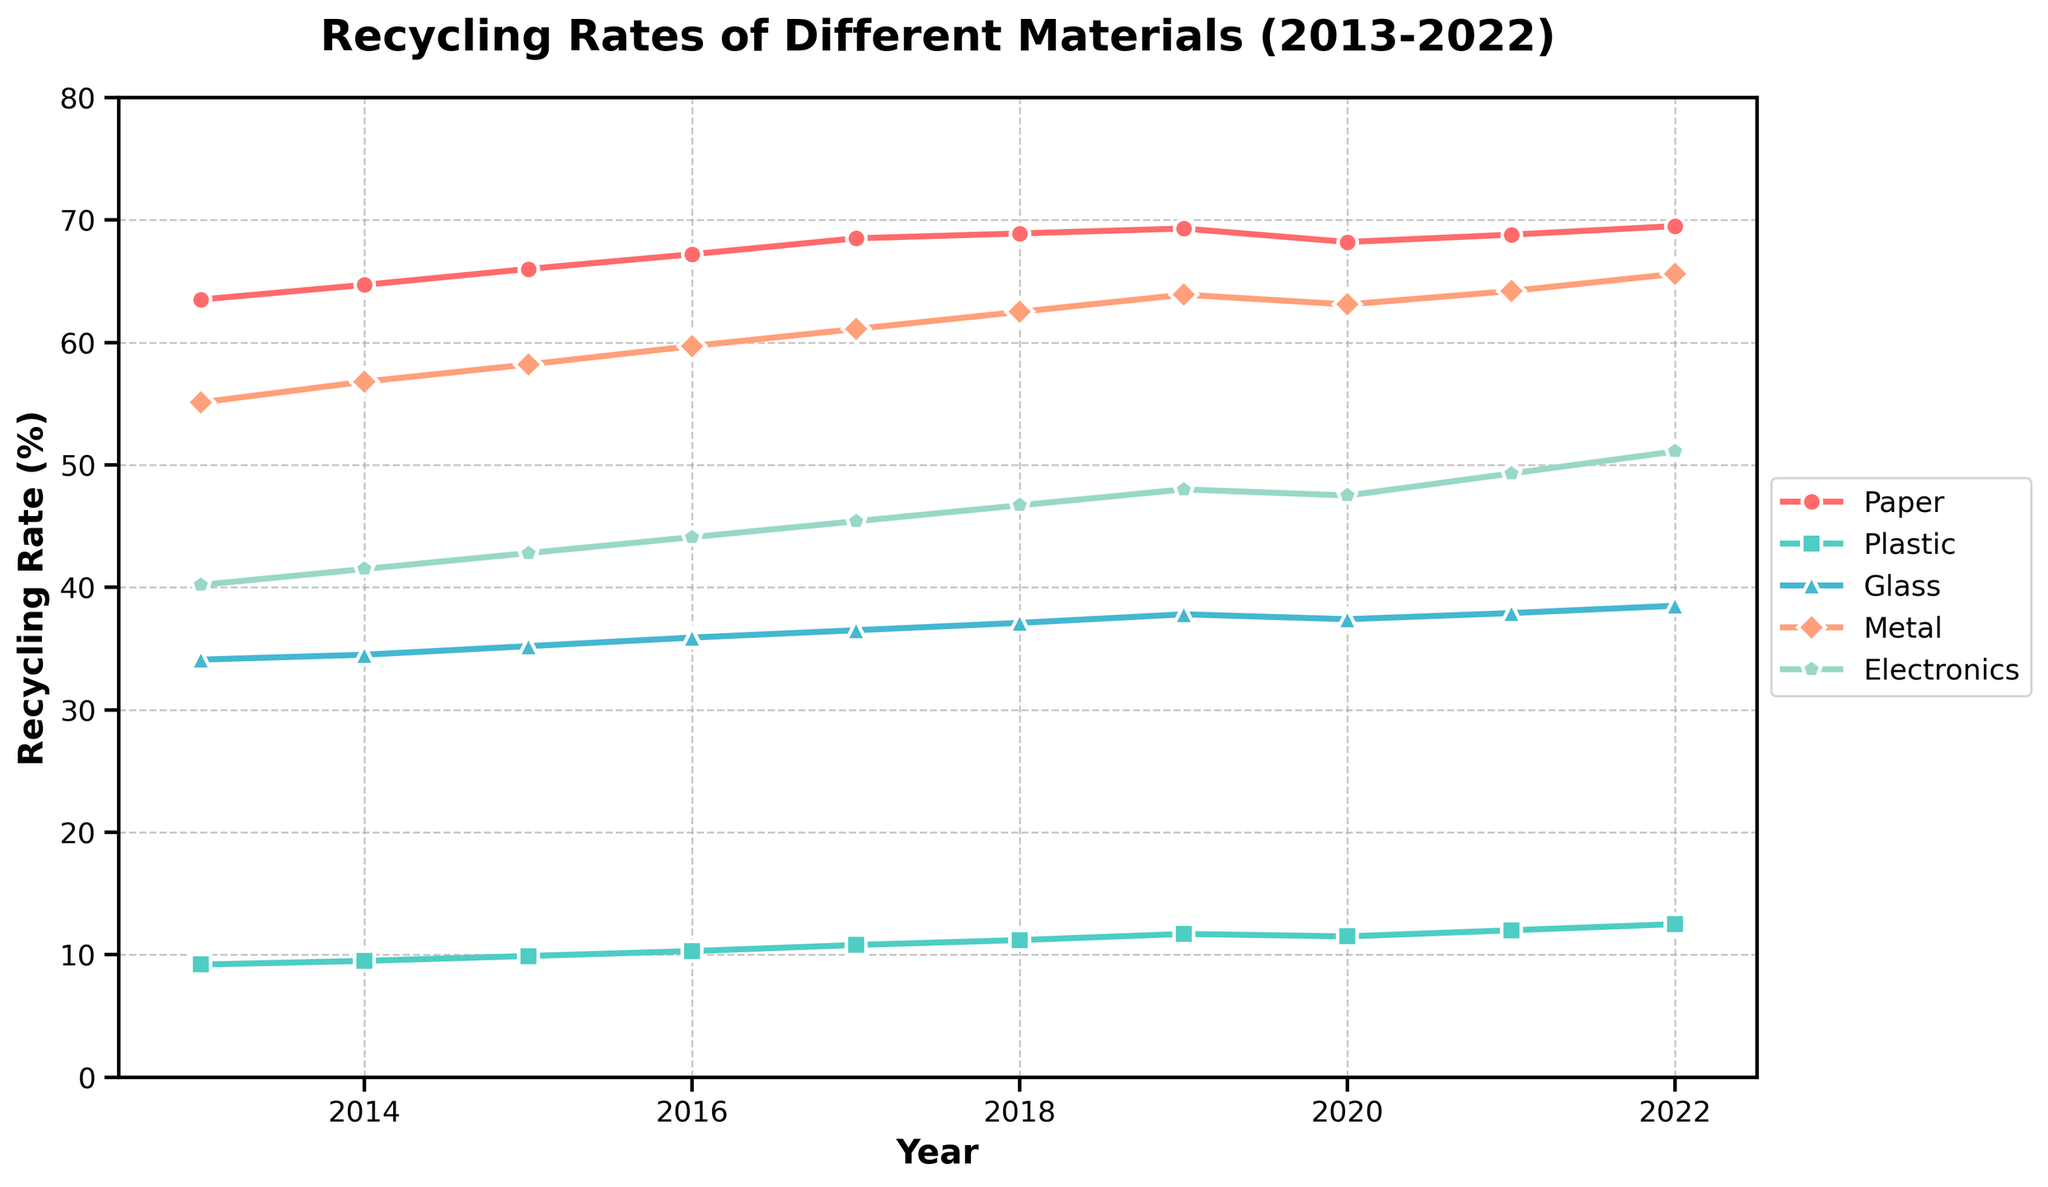What material had the highest recycling rate in 2022? Inspecting the figure, the line representing Paper has the highest value at the rightmost point (2022).
Answer: Paper How has the recycling rate of Plastic changed from 2018 to 2022? Looking at the figure, locate the line for Plastic and compare its value in 2018 and 2022. Plastic has increased from 11.2% in 2018 to 12.5% in 2022.
Answer: Increased by 1.3 percentage points Which material had the lowest recycling rate across all years? By inspecting the lines in the figure, the line for Plastic is consistently the lowest compared to other materials.
Answer: Plastic Between 2015 and 2020, which material experienced the highest increase in recycling rate? Review the data between 2015 and 2020. Paper increased from 66.0% to 68.2%, Plastic from 9.9% to 11.5%, Glass from 35.2% to 37.4%, Metal from 58.2% to 63.1%, and Electronics from 42.8% to 47.5%. Metal saw the biggest increase of 4.9 percentage points.
Answer: Metal What was the average recycling rate of Metal over the decade? Summing the recycling rates for Metal from 2013 to 2022: 55.1 + 56.8 + 58.2 + 59.7 + 61.1 + 62.5 + 63.9 + 63.1 + 64.2 + 65.6 = 610.2. Then divide by 10 years: 610.2 / 10.
Answer: 61.02% During which year did Electronics have the largest annual increase in recycling rate? Compare the vertical distance between the points on the Electronics line year-by-year. The largest increase is between 2021 and 2022 from 49.3% to 51.1%.
Answer: 2021-2022 Visualize the trend of Glass recycling rate; does it show any fluctuations? Inspecting the line for Glass, it shows a consistent upward trend without any notable dips or fluctuations.
Answer: No, it shows a consistent upward trend Compare the recycling rates of Paper and Glass in 2016, which was higher and by how much? Paper's rate in 2016 is 67.2% and Glass’s rate is 35.9%. Subtract the two rates: 67.2 - 35.9 = 31.3%.
Answer: Paper by 31.3 percentage points Which two materials had lines that almost paralleled each other? By visually inspecting the lines, Paper and Metal have a similar upward trend and are closest to being parallel.
Answer: Paper and Metal How did the recycling rate of Electronics change between 2016 and 2018, and what percentage increase does this represent? The rate increased from 44.1% in 2016 to 46.7% in 2018, a difference of 46.7 - 44.1 = 2.6 percentage points. The percentage increase is (2.6/44.1) * 100 ≈ 5.9%.
Answer: Increased by 2.6 percentage points (~5.9%) 